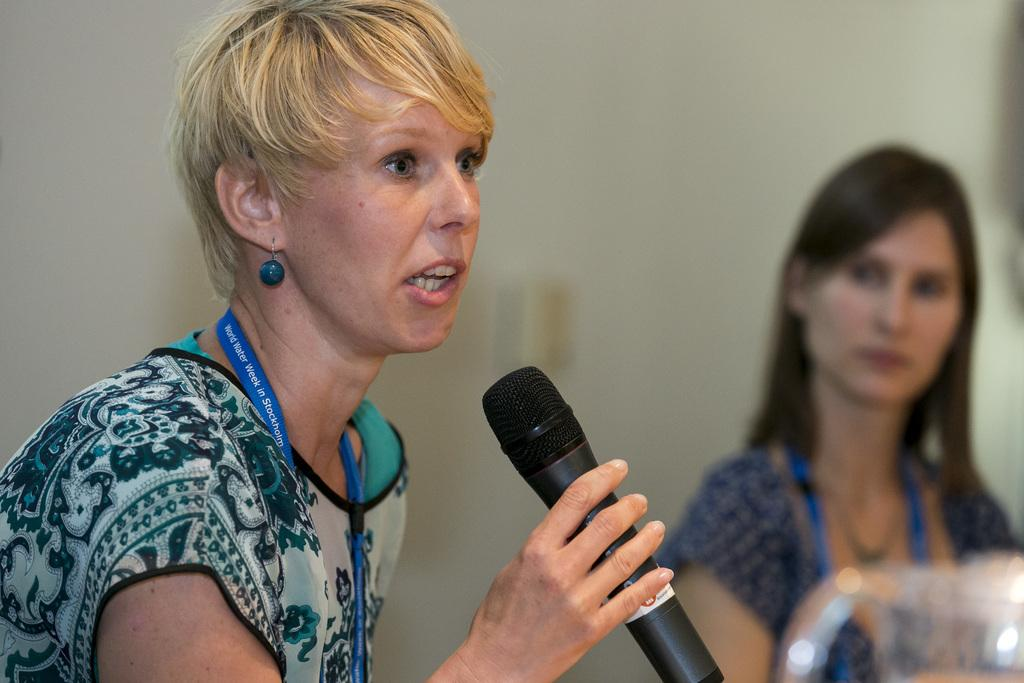What is the woman in the image holding? The woman is holding a mic. Can you describe the setting or activity in the image? The woman holding the mic might be in a performance or speaking engagement. Is there anyone else visible in the image? Yes, there is another woman in the background of the image. What type of rings can be seen on the woman's fingers in the image? There is no mention of rings or any jewelry on the woman's fingers in the image. What emotion does the woman in the image display? The image does not provide enough information to determine the woman's emotions or expressions. 